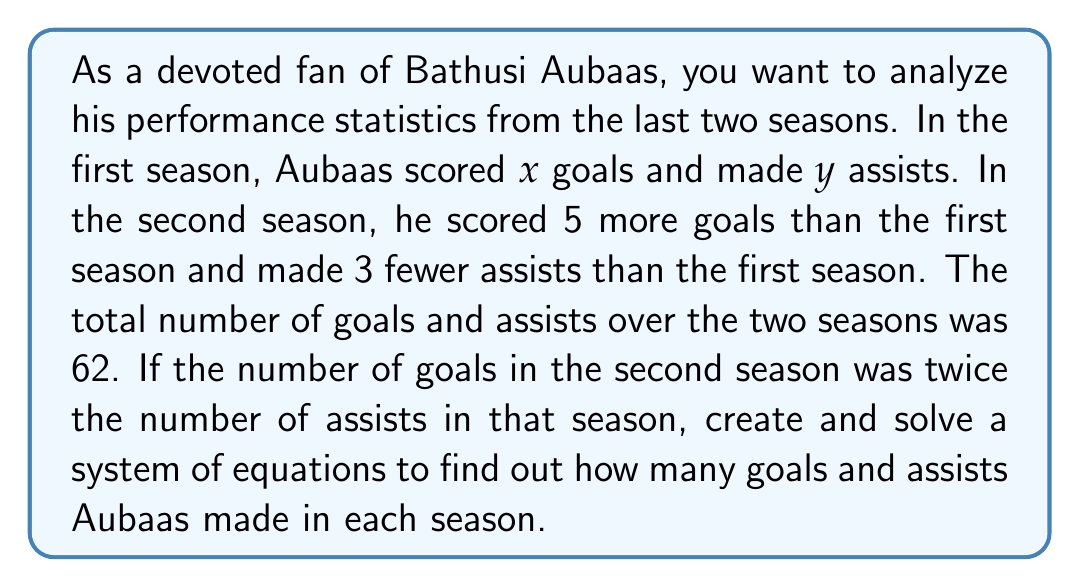Show me your answer to this math problem. Let's approach this step-by-step:

1) Define variables:
   $x$ = number of goals in the first season
   $y$ = number of assists in the first season

2) Create equations based on the given information:

   Equation 1: Total goals and assists over two seasons
   $$(x + y) + ((x + 5) + (y - 3)) = 62$$

   Equation 2: Goals in second season are twice the assists in second season
   $$(x + 5) = 2(y - 3)$$

3) Simplify Equation 1:
   $$2x + 2y + 2 = 62$$
   $$2x + 2y = 60$$ ... (Eq. 1)

4) Simplify Equation 2:
   $$x + 5 = 2y - 6$$
   $$x = 2y - 11$$ ... (Eq. 2)

5) Substitute Eq. 2 into Eq. 1:
   $$2(2y - 11) + 2y = 60$$
   $$4y - 22 + 2y = 60$$
   $$6y - 22 = 60$$
   $$6y = 82$$
   $$y = \frac{82}{6} = \frac{41}{3}$$

6) Substitute $y = \frac{41}{3}$ into Eq. 2:
   $$x = 2(\frac{41}{3}) - 11 = \frac{82}{3} - 11 = \frac{82}{3} - \frac{33}{3} = \frac{49}{3}$$

7) Calculate goals and assists for the second season:
   Goals: $x + 5 = \frac{49}{3} + 5 = \frac{64}{3}$
   Assists: $y - 3 = \frac{41}{3} - 3 = \frac{32}{3}$
Answer: First season: $\frac{49}{3}$ goals, $\frac{41}{3}$ assists
Second season: $\frac{64}{3}$ goals, $\frac{32}{3}$ assists 